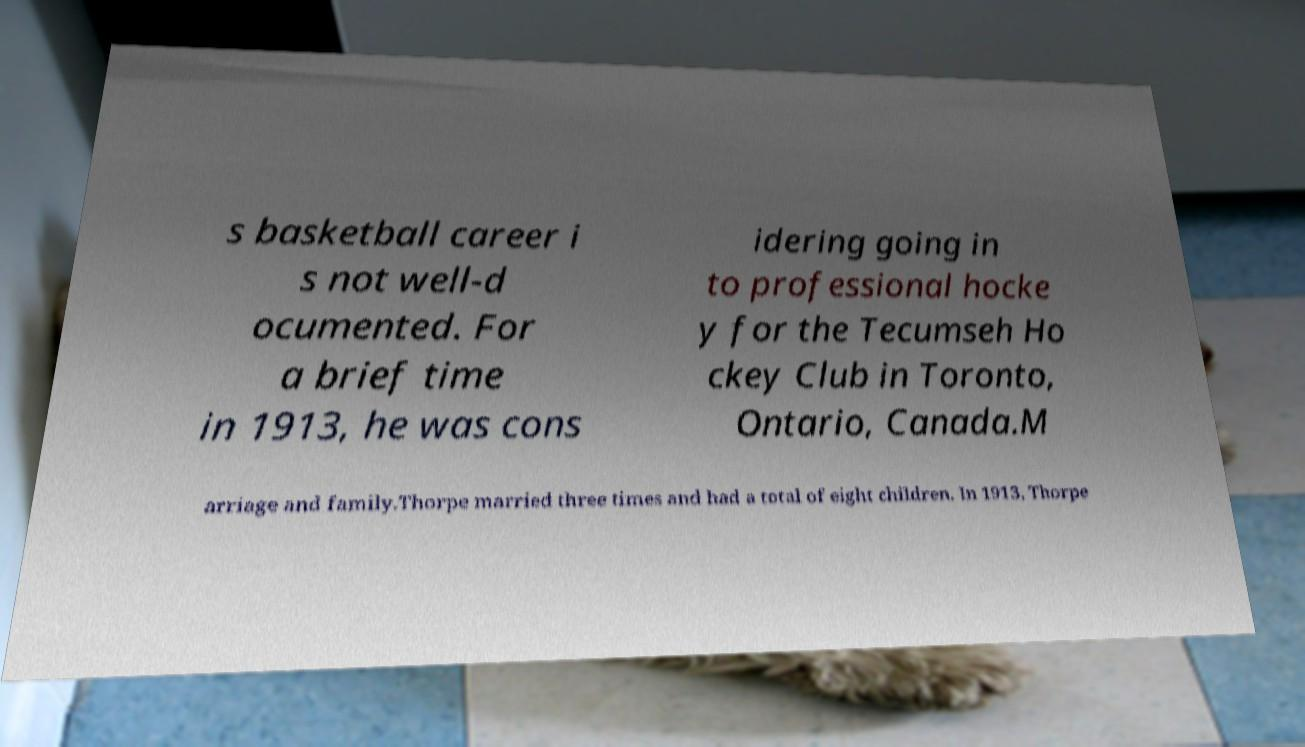For documentation purposes, I need the text within this image transcribed. Could you provide that? s basketball career i s not well-d ocumented. For a brief time in 1913, he was cons idering going in to professional hocke y for the Tecumseh Ho ckey Club in Toronto, Ontario, Canada.M arriage and family.Thorpe married three times and had a total of eight children. In 1913, Thorpe 